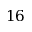Convert formula to latex. <formula><loc_0><loc_0><loc_500><loc_500>1 6</formula> 